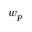<formula> <loc_0><loc_0><loc_500><loc_500>w _ { p }</formula> 